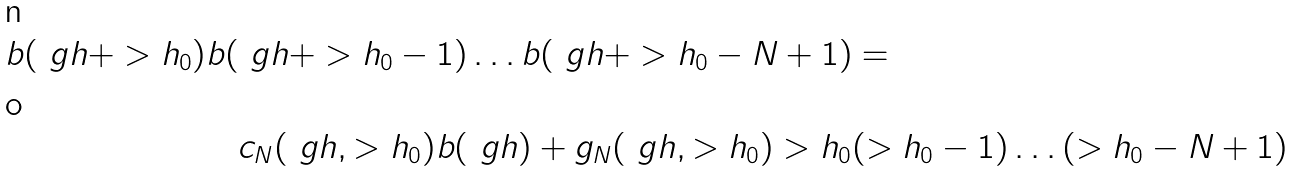<formula> <loc_0><loc_0><loc_500><loc_500>b ( \ g h + > h _ { 0 } ) b ( \ g h + > h _ { 0 } - 1 ) \dots b ( \ g h + > h _ { 0 } - N + 1 ) & = \\ c _ { N } ( \ g h , > h _ { 0 } ) b ( \ g h ) + g _ { N } ( \ g h , > h _ { 0 } ) > h _ { 0 } & ( > h _ { 0 } - 1 ) \dots ( > h _ { 0 } - N + 1 )</formula> 